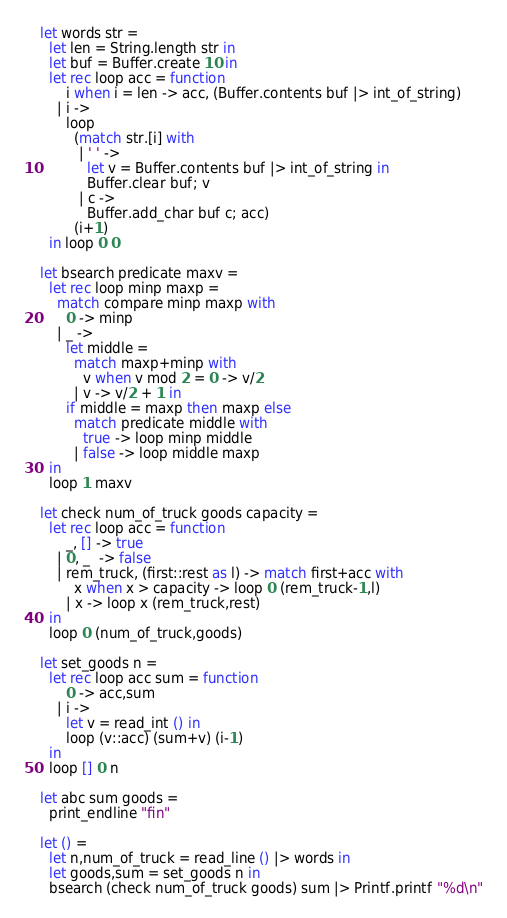<code> <loc_0><loc_0><loc_500><loc_500><_OCaml_>let words str =
  let len = String.length str in
  let buf = Buffer.create 10 in
  let rec loop acc = function
      i when i = len -> acc, (Buffer.contents buf |> int_of_string)
    | i ->
      loop
        (match str.[i] with
         | ' ' ->
           let v = Buffer.contents buf |> int_of_string in
           Buffer.clear buf; v
         | c ->
           Buffer.add_char buf c; acc)
        (i+1)
  in loop 0 0

let bsearch predicate maxv =
  let rec loop minp maxp =
    match compare minp maxp with
      0 -> minp
    | _ ->
      let middle =
        match maxp+minp with
          v when v mod 2 = 0 -> v/2
        | v -> v/2 + 1 in
      if middle = maxp then maxp else
        match predicate middle with
          true -> loop minp middle
        | false -> loop middle maxp
  in
  loop 1 maxv

let check num_of_truck goods capacity =
  let rec loop acc = function
      _, [] -> true
    | 0, _  -> false
    | rem_truck, (first::rest as l) -> match first+acc with
        x when x > capacity -> loop 0 (rem_truck-1,l)
      | x -> loop x (rem_truck,rest)
  in
  loop 0 (num_of_truck,goods)

let set_goods n =
  let rec loop acc sum = function
      0 -> acc,sum
    | i ->
      let v = read_int () in
      loop (v::acc) (sum+v) (i-1)
  in
  loop [] 0 n

let abc sum goods =
  print_endline "fin"
    
let () =
  let n,num_of_truck = read_line () |> words in
  let goods,sum = set_goods n in
  bsearch (check num_of_truck goods) sum |> Printf.printf "%d\n"</code> 